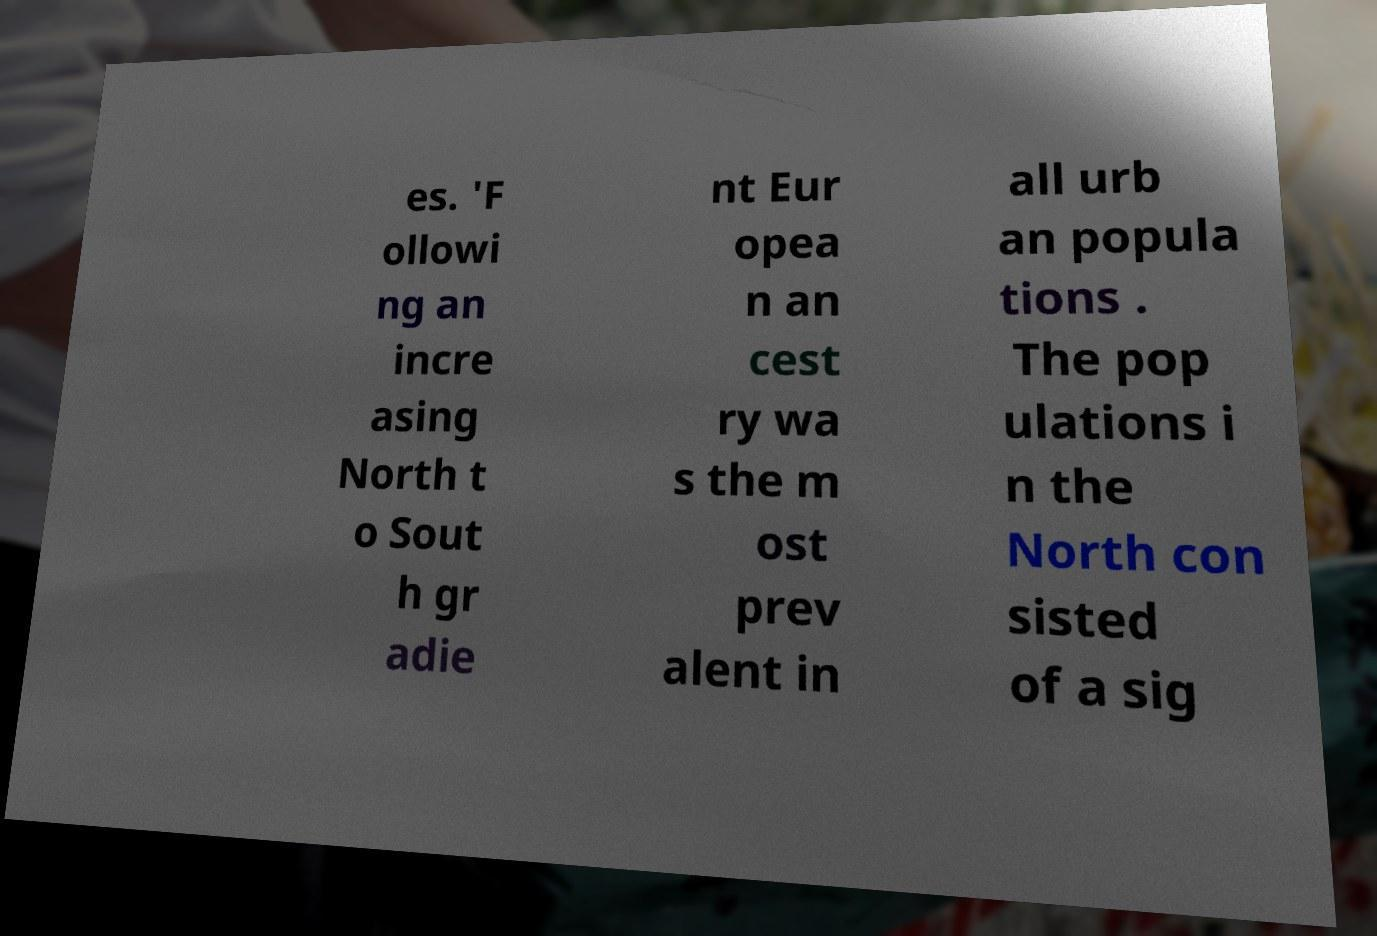Could you extract and type out the text from this image? es. 'F ollowi ng an incre asing North t o Sout h gr adie nt Eur opea n an cest ry wa s the m ost prev alent in all urb an popula tions . The pop ulations i n the North con sisted of a sig 